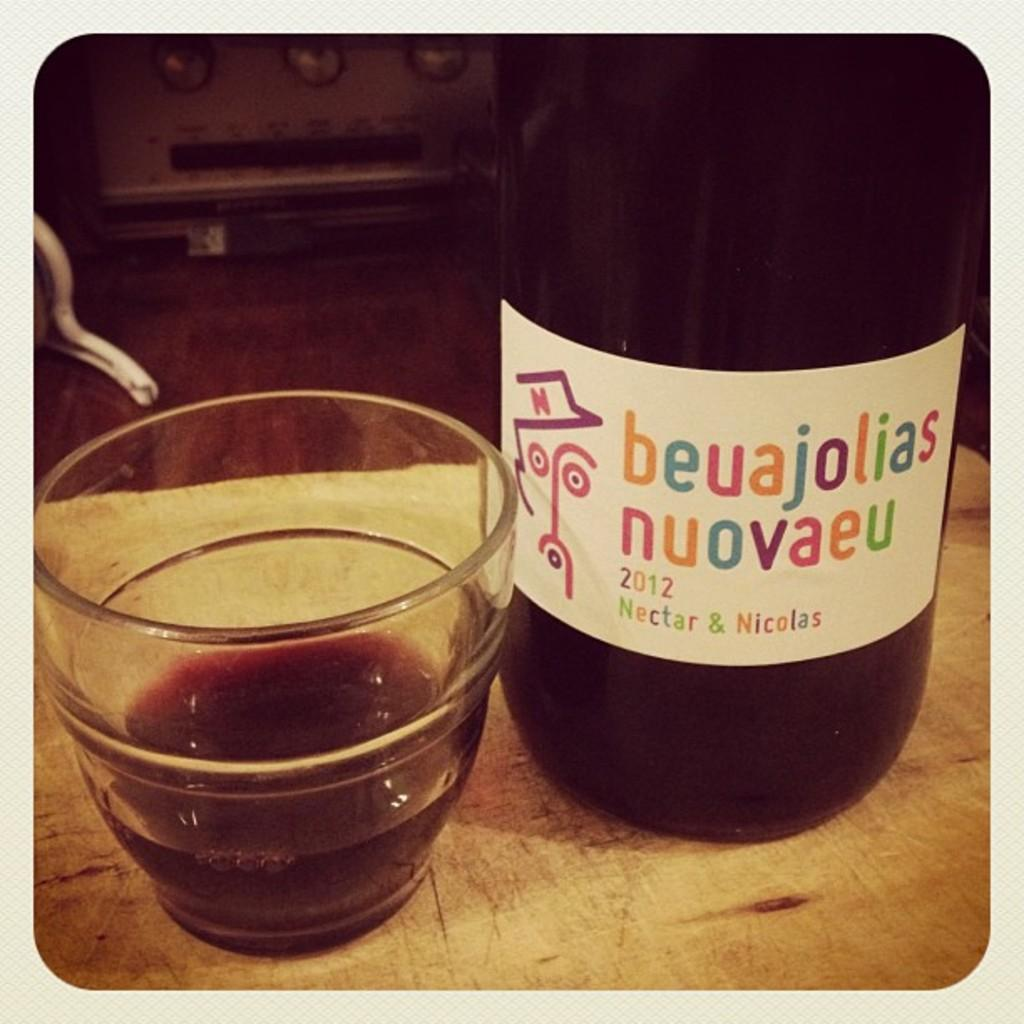Provide a one-sentence caption for the provided image. A glass sitting next to a bottle of beuajolias nuovaeu 2012. 